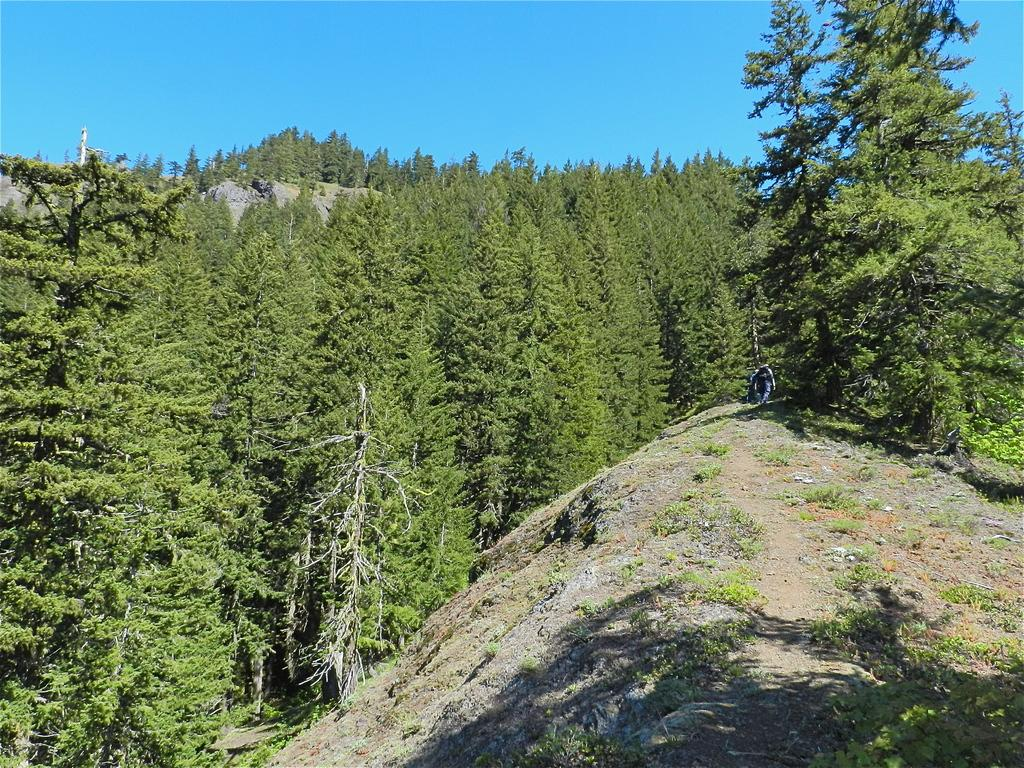What color are the trees in the image? The trees in the image are green. What color is the sky in the image? The sky is blue in the image. Can you tell me how many yoke are hanging from the trees in the image? There are no yoke present in the image; it only features green trees and a blue sky. Are there any jellyfish visible in the image? There are no jellyfish present in the image, as it is a landscape featuring trees and a sky. 